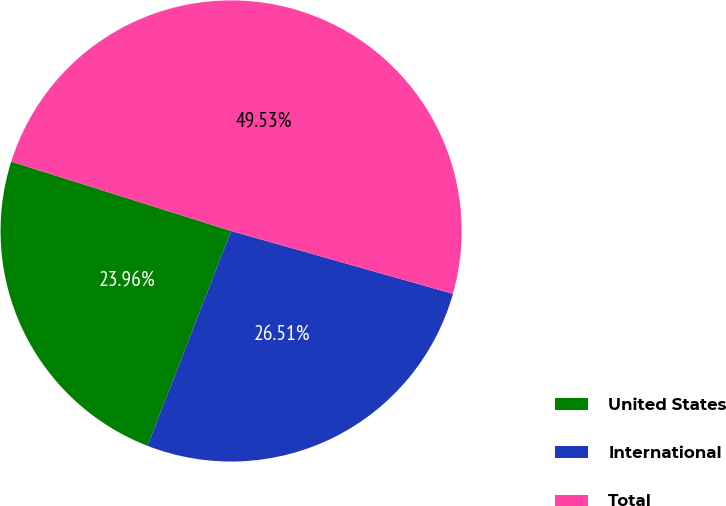Convert chart. <chart><loc_0><loc_0><loc_500><loc_500><pie_chart><fcel>United States<fcel>International<fcel>Total<nl><fcel>23.96%<fcel>26.51%<fcel>49.53%<nl></chart> 